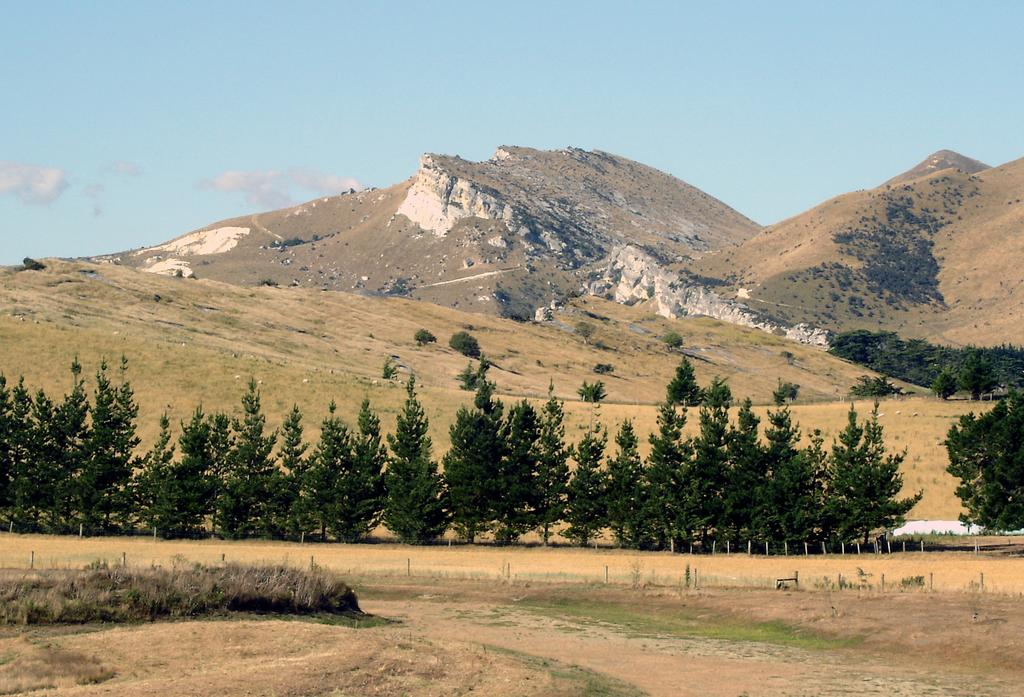What can be seen in the foreground of the picture? In the foreground of the picture, there are shrubs, fencing, and land. What is located in the center of the picture? In the center of the picture, there are trees, grass, and a mountain. How would you describe the weather in the image? The sky is sunny, indicating a clear and likely warm day. What type of hair design can be seen on the mountain in the image? There is no hair or hair design present in the image, as it features a mountain in the center of the picture. What is the tin doing in the foreground of the image? There is no tin present in the image; it features shrubs, fencing, and land in the foreground. 